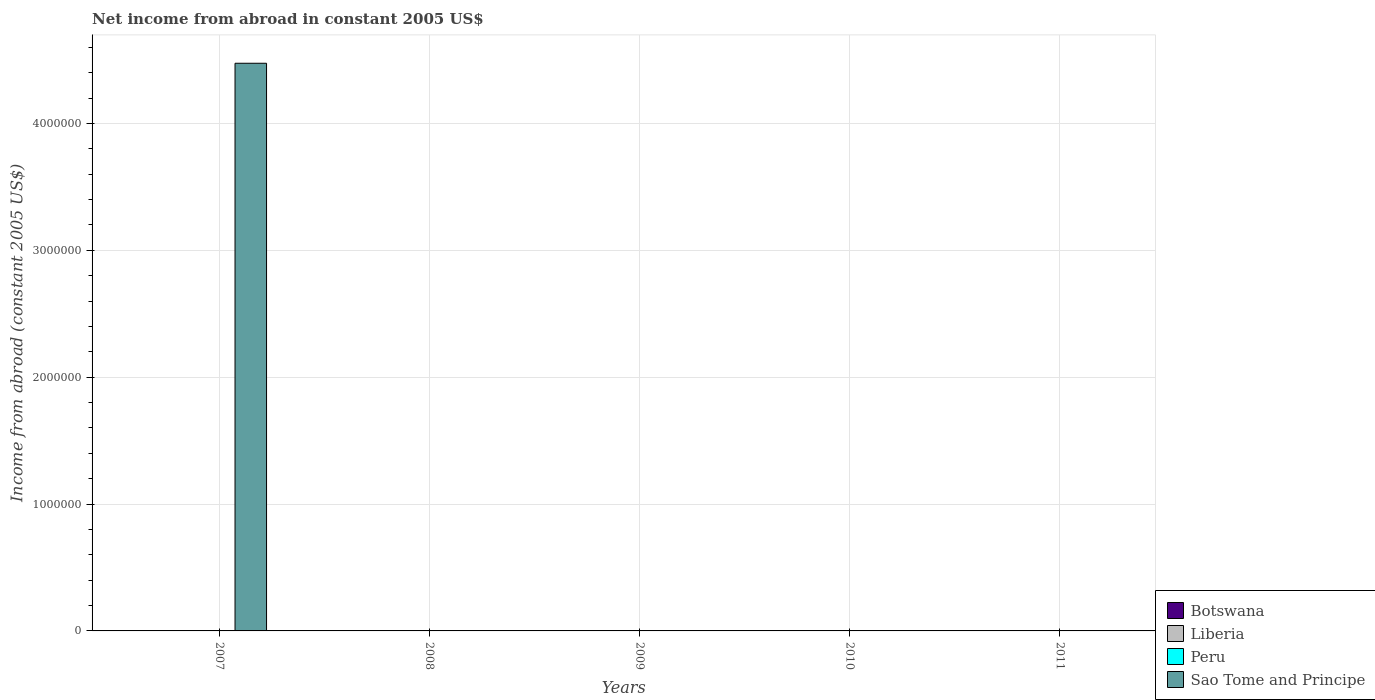How many different coloured bars are there?
Your answer should be very brief. 1. Are the number of bars on each tick of the X-axis equal?
Your answer should be very brief. No. How many bars are there on the 5th tick from the left?
Keep it short and to the point. 0. How many bars are there on the 3rd tick from the right?
Your answer should be compact. 0. What is the label of the 5th group of bars from the left?
Your answer should be very brief. 2011. What is the net income from abroad in Peru in 2009?
Your response must be concise. 0. Across all years, what is the maximum net income from abroad in Sao Tome and Principe?
Offer a very short reply. 4.47e+06. Across all years, what is the minimum net income from abroad in Liberia?
Ensure brevity in your answer.  0. What is the total net income from abroad in Liberia in the graph?
Your answer should be compact. 0. What is the difference between the net income from abroad in Sao Tome and Principe in 2007 and the net income from abroad in Botswana in 2008?
Make the answer very short. 4.47e+06. What is the average net income from abroad in Sao Tome and Principe per year?
Your response must be concise. 8.95e+05. What is the difference between the highest and the lowest net income from abroad in Sao Tome and Principe?
Keep it short and to the point. 4.47e+06. In how many years, is the net income from abroad in Liberia greater than the average net income from abroad in Liberia taken over all years?
Your answer should be very brief. 0. Is it the case that in every year, the sum of the net income from abroad in Liberia and net income from abroad in Botswana is greater than the sum of net income from abroad in Sao Tome and Principe and net income from abroad in Peru?
Provide a short and direct response. No. Are all the bars in the graph horizontal?
Offer a very short reply. No. How many years are there in the graph?
Your answer should be compact. 5. What is the difference between two consecutive major ticks on the Y-axis?
Your answer should be very brief. 1.00e+06. Does the graph contain any zero values?
Offer a very short reply. Yes. Where does the legend appear in the graph?
Offer a very short reply. Bottom right. How many legend labels are there?
Your response must be concise. 4. How are the legend labels stacked?
Ensure brevity in your answer.  Vertical. What is the title of the graph?
Give a very brief answer. Net income from abroad in constant 2005 US$. Does "Mexico" appear as one of the legend labels in the graph?
Ensure brevity in your answer.  No. What is the label or title of the Y-axis?
Keep it short and to the point. Income from abroad (constant 2005 US$). What is the Income from abroad (constant 2005 US$) in Botswana in 2007?
Offer a very short reply. 0. What is the Income from abroad (constant 2005 US$) of Liberia in 2007?
Provide a succinct answer. 0. What is the Income from abroad (constant 2005 US$) in Sao Tome and Principe in 2007?
Provide a short and direct response. 4.47e+06. What is the Income from abroad (constant 2005 US$) of Botswana in 2008?
Ensure brevity in your answer.  0. What is the Income from abroad (constant 2005 US$) in Peru in 2008?
Keep it short and to the point. 0. What is the Income from abroad (constant 2005 US$) in Peru in 2009?
Ensure brevity in your answer.  0. What is the Income from abroad (constant 2005 US$) in Botswana in 2010?
Give a very brief answer. 0. What is the Income from abroad (constant 2005 US$) in Liberia in 2010?
Your answer should be compact. 0. What is the Income from abroad (constant 2005 US$) of Botswana in 2011?
Keep it short and to the point. 0. What is the Income from abroad (constant 2005 US$) in Sao Tome and Principe in 2011?
Provide a succinct answer. 0. Across all years, what is the maximum Income from abroad (constant 2005 US$) of Sao Tome and Principe?
Your answer should be very brief. 4.47e+06. What is the total Income from abroad (constant 2005 US$) of Botswana in the graph?
Your response must be concise. 0. What is the total Income from abroad (constant 2005 US$) of Liberia in the graph?
Ensure brevity in your answer.  0. What is the total Income from abroad (constant 2005 US$) in Sao Tome and Principe in the graph?
Provide a succinct answer. 4.47e+06. What is the average Income from abroad (constant 2005 US$) in Liberia per year?
Keep it short and to the point. 0. What is the average Income from abroad (constant 2005 US$) in Peru per year?
Make the answer very short. 0. What is the average Income from abroad (constant 2005 US$) in Sao Tome and Principe per year?
Ensure brevity in your answer.  8.95e+05. What is the difference between the highest and the lowest Income from abroad (constant 2005 US$) in Sao Tome and Principe?
Your answer should be very brief. 4.47e+06. 